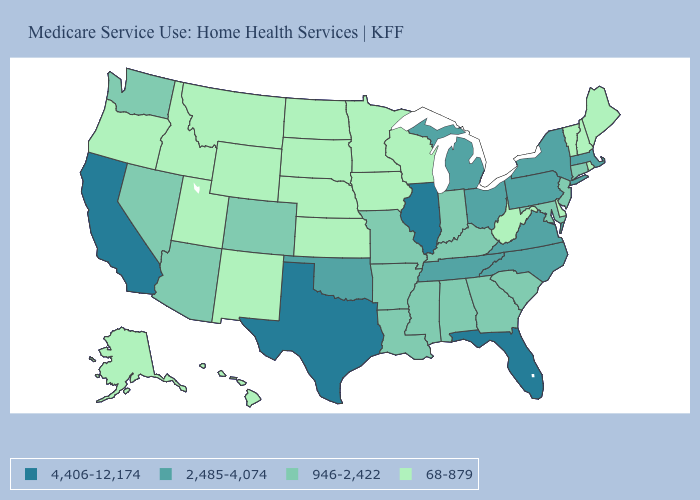Does the first symbol in the legend represent the smallest category?
Keep it brief. No. Among the states that border Idaho , does Montana have the lowest value?
Short answer required. Yes. Which states hav the highest value in the West?
Answer briefly. California. Name the states that have a value in the range 68-879?
Answer briefly. Alaska, Delaware, Hawaii, Idaho, Iowa, Kansas, Maine, Minnesota, Montana, Nebraska, New Hampshire, New Mexico, North Dakota, Oregon, Rhode Island, South Dakota, Utah, Vermont, West Virginia, Wisconsin, Wyoming. Which states have the highest value in the USA?
Give a very brief answer. California, Florida, Illinois, Texas. What is the lowest value in states that border Vermont?
Write a very short answer. 68-879. Name the states that have a value in the range 2,485-4,074?
Give a very brief answer. Massachusetts, Michigan, New York, North Carolina, Ohio, Oklahoma, Pennsylvania, Tennessee, Virginia. Name the states that have a value in the range 4,406-12,174?
Concise answer only. California, Florida, Illinois, Texas. Name the states that have a value in the range 68-879?
Answer briefly. Alaska, Delaware, Hawaii, Idaho, Iowa, Kansas, Maine, Minnesota, Montana, Nebraska, New Hampshire, New Mexico, North Dakota, Oregon, Rhode Island, South Dakota, Utah, Vermont, West Virginia, Wisconsin, Wyoming. What is the lowest value in states that border Arizona?
Give a very brief answer. 68-879. Among the states that border North Carolina , does Georgia have the highest value?
Concise answer only. No. Which states have the lowest value in the South?
Quick response, please. Delaware, West Virginia. Which states have the highest value in the USA?
Answer briefly. California, Florida, Illinois, Texas. Name the states that have a value in the range 2,485-4,074?
Write a very short answer. Massachusetts, Michigan, New York, North Carolina, Ohio, Oklahoma, Pennsylvania, Tennessee, Virginia. Does California have the highest value in the West?
Give a very brief answer. Yes. 